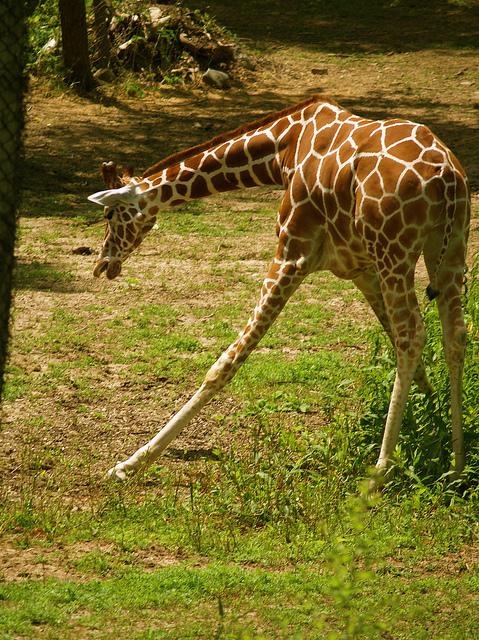Where is the animal standing?
Quick response, please. Grass. What color is the grass?
Write a very short answer. Green. Is this giraffe sad?
Quick response, please. No. Is the giraffe eating?
Answer briefly. No. How many giraffes are in the picture?
Write a very short answer. 1. How many giraffes are there?
Concise answer only. 1. Is this animal in the jungle?
Write a very short answer. No. Is the giraffe a baby or an adult?
Concise answer only. Baby. Is the giraffe grazing?
Give a very brief answer. Yes. How giraffes do you see?
Keep it brief. 1. What is this animal eating?
Concise answer only. Grass. 